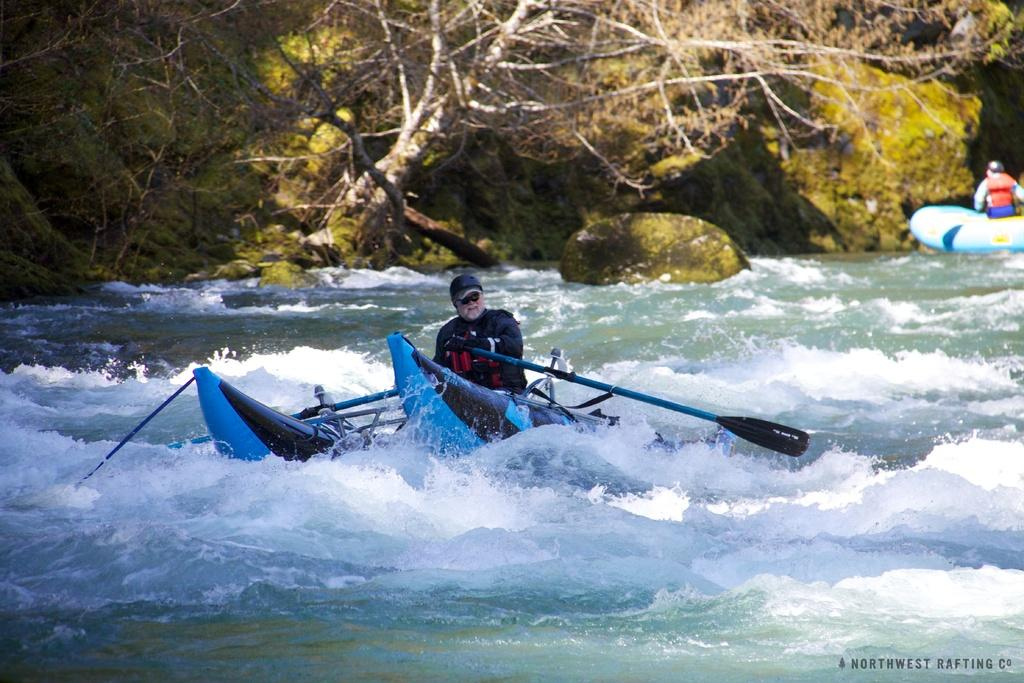What is the main subject of the image? There is a man on a boat in the image. What can be seen around the boat? There are waves and water in the image. What is written or depicted in the image? There is a text in the image. Can you describe the background of the image? There is a man, another boat, stones, and trees in the background of the image. What type of farm can be seen in the background of the image? There is no farm present in the image; it features a man on a boat surrounded by water, with a background that includes a man, another boat, stones, and trees. 